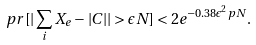Convert formula to latex. <formula><loc_0><loc_0><loc_500><loc_500>\ p r [ | \sum _ { i } X _ { e } - | C | | > \epsilon N ] < 2 e ^ { - 0 . 3 8 \epsilon ^ { 2 } p N } .</formula> 